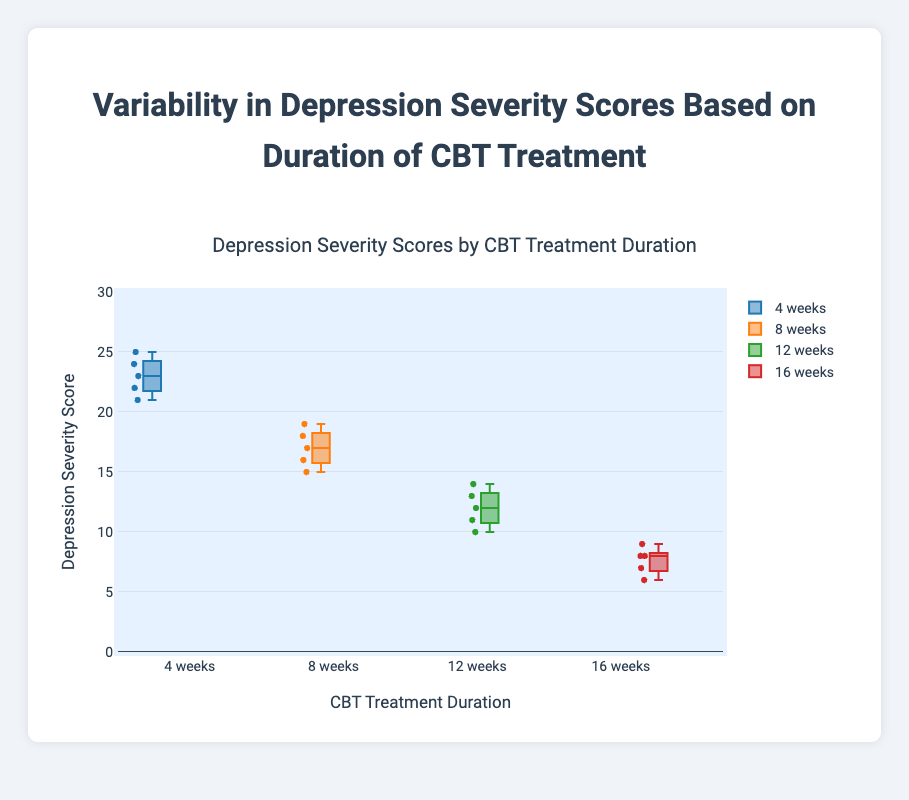which treatment duration has the highest median severity score? Identify the boxplot with the highest central line (median). The "4 weeks" duration has the highest median severity score.
Answer: 4 weeks what is the median severity score for the 12 weeks treatment duration? Look at the central line within the 12 weeks boxplot to identify the median value.
Answer: 12 which treatment duration shows the least variability in severity scores? Identify the boxplot with the shortest height from the first quartile to the third quartile, as it indicates less variability. The "8 weeks" duration shows the least variability.
Answer: 8 weeks how do the median severity scores change with increasing treatment duration? Observe the median lines across four durations. The medians decrease: 4 weeks > 8 weeks > 12 weeks > 16 weeks.
Answer: Decrease what's the range of severity scores for the 16 weeks treatment duration? Identify the lower and upper whiskers for 16 weeks. The range is from 6 to 9.
Answer: 6 to 9 which treatment duration shows the maximum spread or range of severity scores? Find the duration with the longest distance between the upper and lower whiskers. The "4 weeks" duration shows the maximum spread.
Answer: 4 weeks comparing 8 weeks and 12 weeks treatment durations, which one has a lower interquartile range (IQR)? Calculate IQR by subtracting Q1 from Q3 for both. "8 weeks" IQR (19-16 = 3) and "12 weeks" IQR (14-11 = 3). Both have equal IQRs.
Answer: Equal which treatment duration has the most number of distinct data points? Count the distinct data points within each duration's correspond box and whiskers. All durations have 5 distinct data points each.
Answer: All equal are there any outliers in the depression severity scores for any of the treatment durations? Check for any data points outside the whiskers. No outliers are present in any duration.
Answer: No 